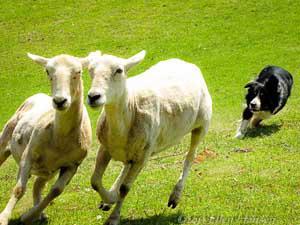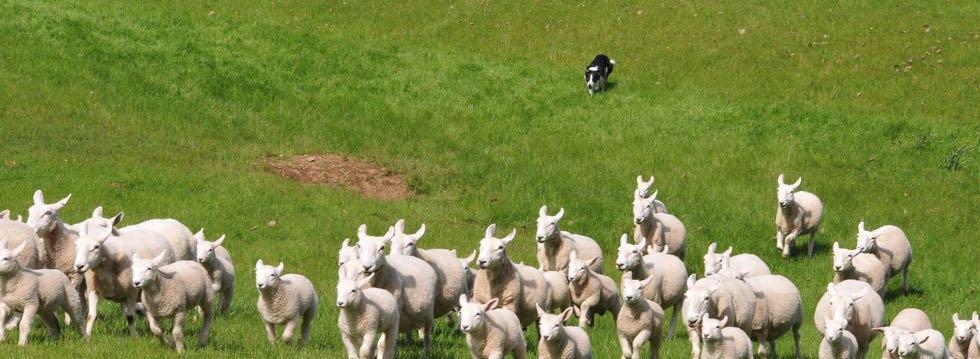The first image is the image on the left, the second image is the image on the right. Examine the images to the left and right. Is the description "At least one image shows a dog at the right herding no more than three sheep, which are at the left." accurate? Answer yes or no. Yes. 